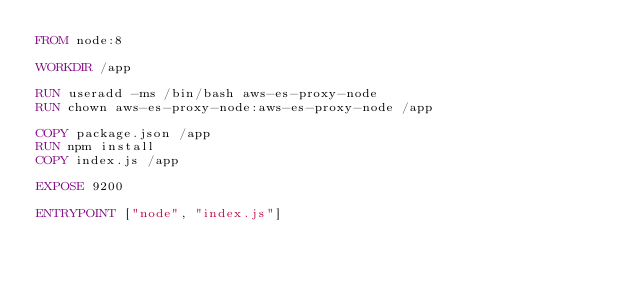Convert code to text. <code><loc_0><loc_0><loc_500><loc_500><_Dockerfile_>FROM node:8

WORKDIR /app

RUN useradd -ms /bin/bash aws-es-proxy-node
RUN chown aws-es-proxy-node:aws-es-proxy-node /app

COPY package.json /app
RUN npm install
COPY index.js /app

EXPOSE 9200

ENTRYPOINT ["node", "index.js"]
</code> 